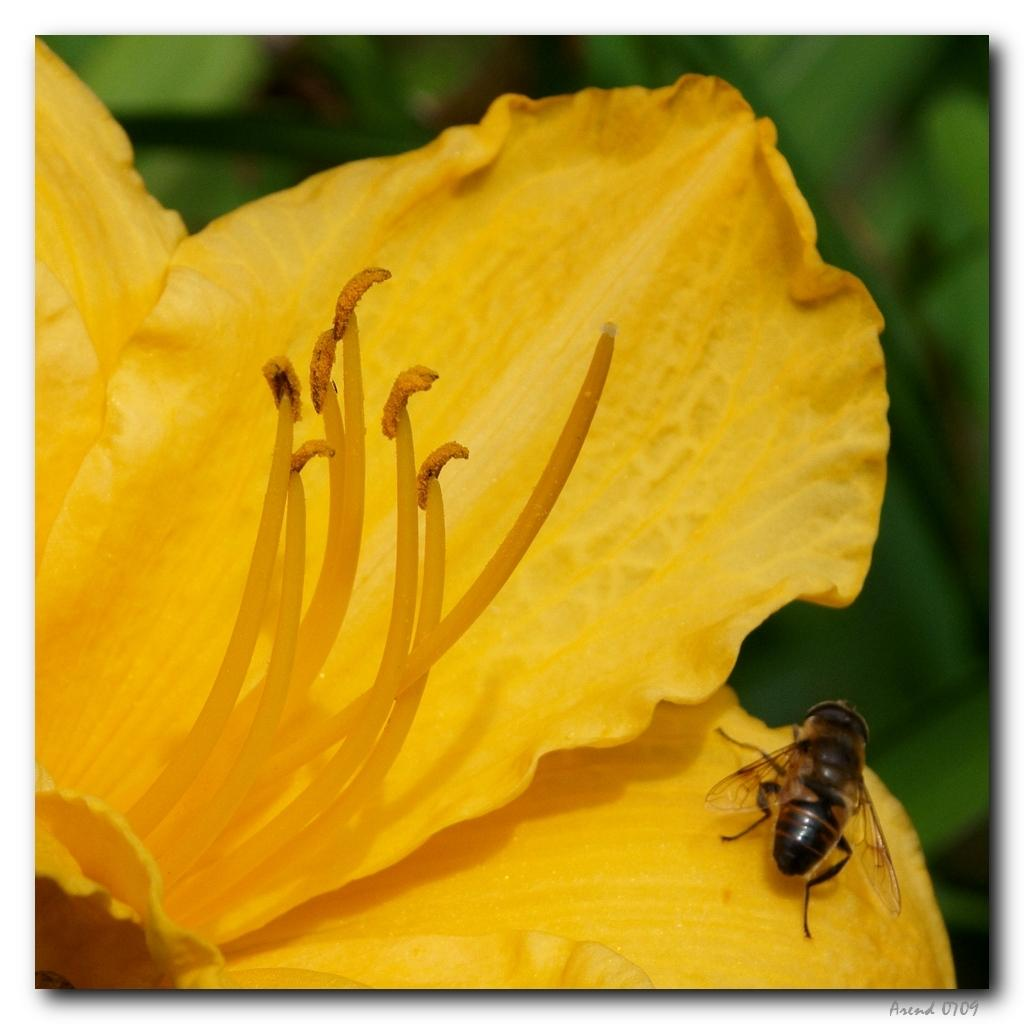What type of flower is present in the image? There is a yellow flower in the image. Are there any other living organisms in the image besides the flower? Yes, there is an insect in the image. Can you describe the background of the image? The background of the image is blurred. How does the frog contribute to the image? There is no frog present in the image. What type of smoke can be seen coming from the flower in the image? There is no smoke present in the image. 